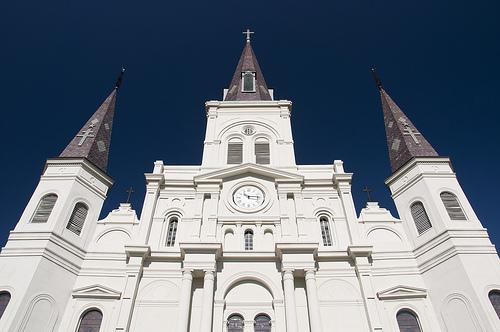Question: what color is the building?
Choices:
A. Gray.
B. Brown.
C. Red.
D. White.
Answer with the letter. Answer: D Question: where is the clock?
Choices:
A. On a table.
B. On the floor.
C. Center of the building.
D. Over the counter.
Answer with the letter. Answer: C Question: how many crosses can be seen?
Choices:
A. 6.
B. 2.
C. 1.
D. 3.
Answer with the letter. Answer: D Question: why is there are cross on top?
Choices:
A. To show it is a church.
B. It's a grave.
C. It marks the spot.
D. It is wrong.
Answer with the letter. Answer: A Question: what time is it?
Choices:
A. Noon.
B. Midnight.
C. Morning.
D. 11:15.
Answer with the letter. Answer: D 